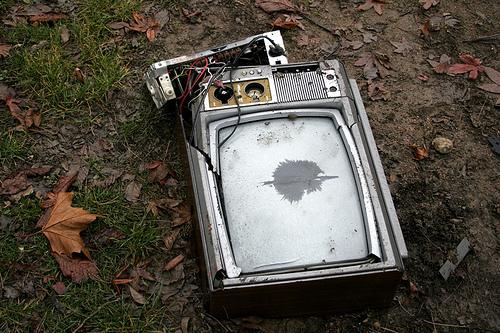Examine the image and list objects that suggest a specific historical era or design style. The antique television and its silver color indicate the favored design schemes of the 1980s era. Tell me the most significant item in the image and explain its state. The most significant item is an antique television circa 1980, which is broken and lying on the ground, with internal circuitry spilling out from its case. Please provide a detailed description of the scene shown in the image. The scene shows a broken and smashed antique television lying on muddy, damp ground with green grass and fallen leaves, with wires and internal components spilling out from its case. Describe the relationship between the television and the environmental elements present in the image. The broken television is laid on damp ground with green grass and dead leaves, showing a contrast between discarded technology and nature's life cycle. Assess the image and provide an interpretation of its sentiment. The image conveys a sense of decay, abandonment, and nostalgia, as it depicts an old, broken television left to nature's elements in the fall season. How many speakers are visible on the television and describe their condition? There is only one speaker visible on the television, which is housed in a ripped speaker grill. Identify the parts of the television that are damaged or missing. The television has cracked casing, a broken screen with a dark spot, missing control knobs, a detached side panel, and a ripped front speaker grill. What is the appearance of the ground, and what signs of the season can you find in the image? The ground appears wet and muddy with greenish-yellow grass and dead maple leaves, suggesting the fall season and recent rain. Analyze the interaction between the objects in the image. The broken television interacts with the damp, muddy ground and fallen leaves, suggesting that it was discarded outdoors and possibly affected by natural elements. Count and describe the different types of leaves you can see in the image? There are three types of leaves: a dead maple leaf, a large brown leaf, and a red leaf, all of which are lying on the ground. 